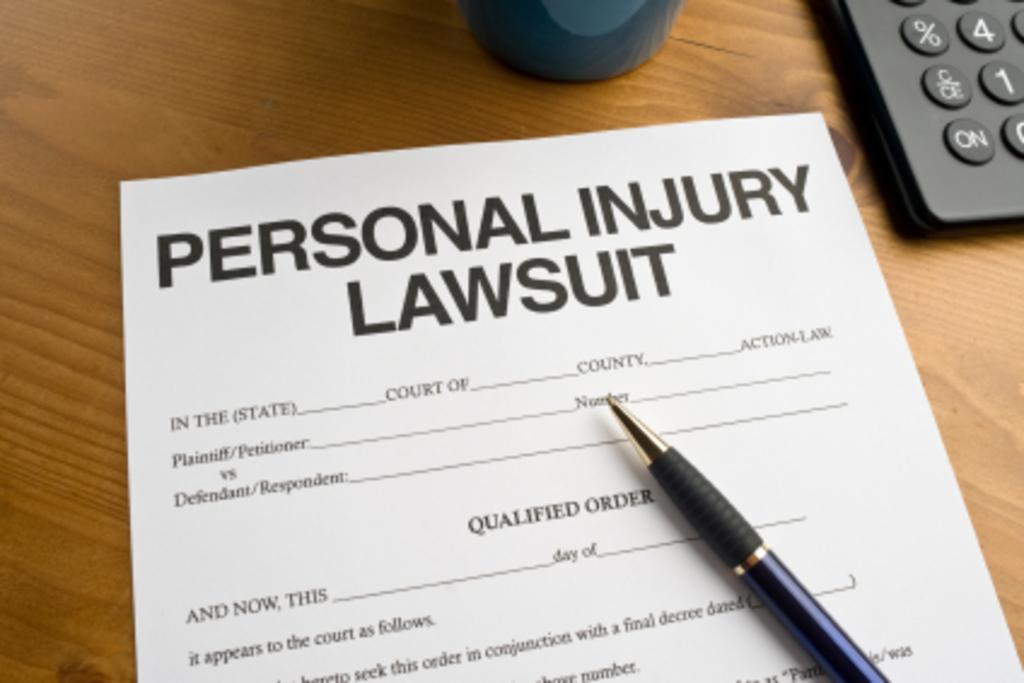What is the first thing you need to fill out on this form?
Offer a very short reply. State. 